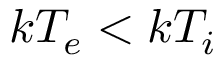<formula> <loc_0><loc_0><loc_500><loc_500>k T _ { e } < k T _ { i }</formula> 